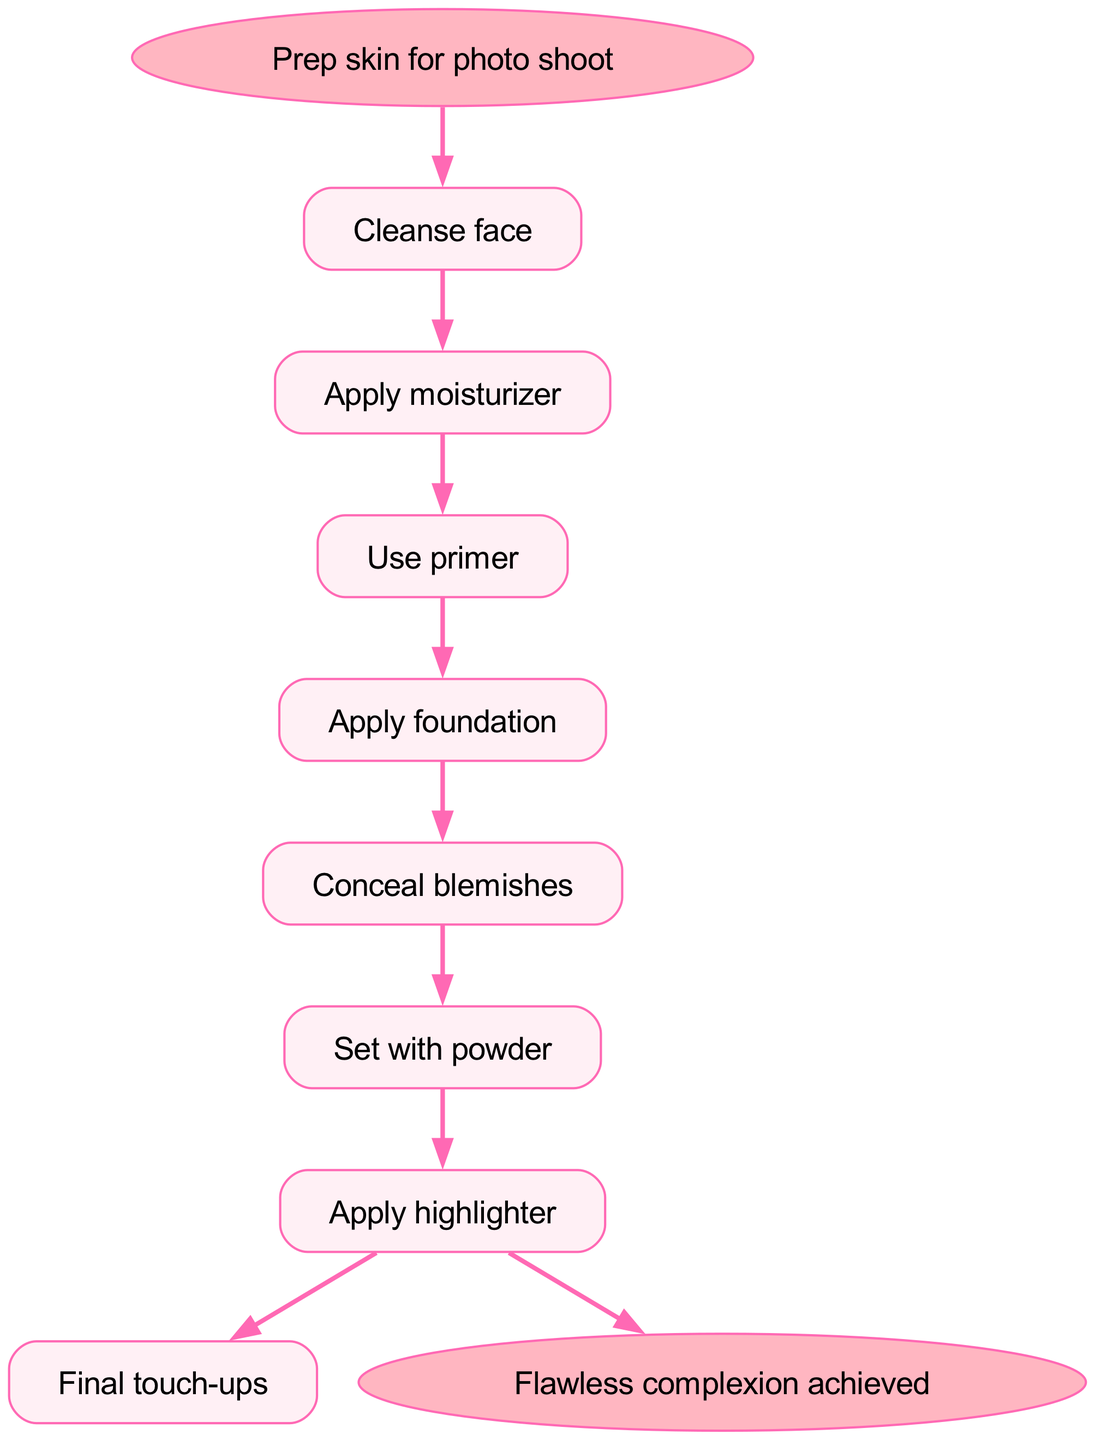What is the starting point of the diagram? The diagram begins with the node labeled "Prep skin for photo shoot," which serves as the entry point for the steps listed in the flow chart.
Answer: Prep skin for photo shoot How many steps are there in the process? By counting each of the steps listed in the flow chart between the start and end nodes, there are a total of 7 distinct steps to follow for achieving a flawless complexion.
Answer: 7 What is the last step in the process? The final step before achieving the flawless complexion, as indicated by the last node before the end node in the diagram, is "Final touch-ups."
Answer: Final touch-ups What comes after "Set with powder"? Following the step "Set with powder," the next step according to the flow chart is "Apply highlighter," which signifies the continuation of the makeup application process.
Answer: Apply highlighter What is the relationship between "Use primer" and "Apply foundation"? "Use primer" is directly followed by "Apply foundation," illustrating that after the primer application, the next logical step is to apply foundation to enhance the complexion.
Answer: Apply foundation What is the last action before achieving a flawless complexion? Before reaching the end node labeled "Flawless complexion achieved," the last action taken in the process is "Apply highlighter," which acts as a penultimate step in the routine.
Answer: Apply highlighter Which step directly follows "Conceal blemishes"? The step that comes directly after "Conceal blemishes" is "Set with powder," indicating that setting the concealer is the next action to solidify the makeup.
Answer: Set with powder How many edges are drawn from the initial start node? From the start node "Prep skin for photo shoot," there is one edge connecting to the first step, "Cleanse face," indicating the first action initiated in the diagram.
Answer: 1 